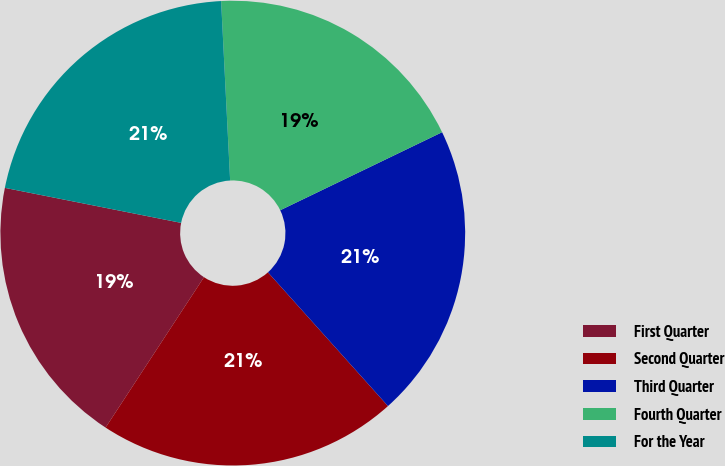Convert chart. <chart><loc_0><loc_0><loc_500><loc_500><pie_chart><fcel>First Quarter<fcel>Second Quarter<fcel>Third Quarter<fcel>Fourth Quarter<fcel>For the Year<nl><fcel>18.9%<fcel>20.86%<fcel>20.51%<fcel>18.65%<fcel>21.08%<nl></chart> 